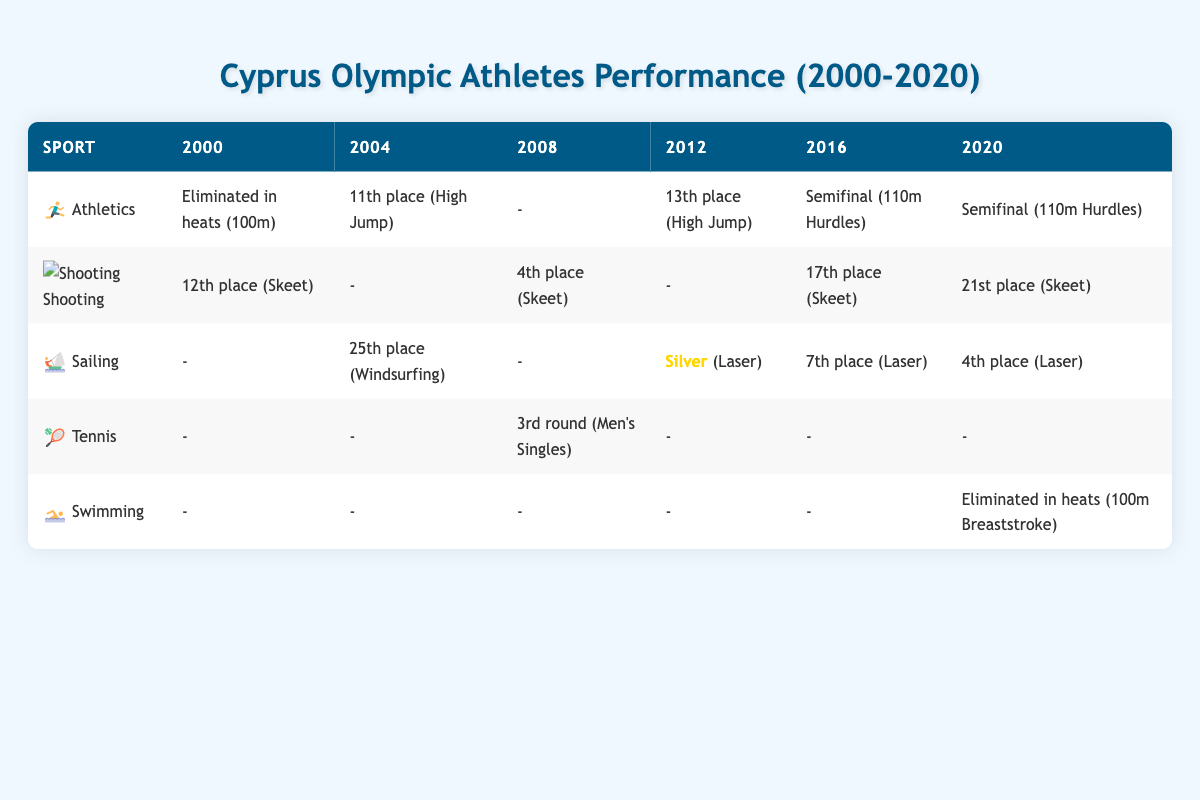What was Pavlos Kontides' best result in the Olympic Games from 2000 to 2020? Pavlos Kontides participated in the Olympics in 2012, 2016, and 2020. In 2012, he won a silver medal in the Laser event, which is his best result. In 2016, he placed 7th and in 2020 he finished 4th.
Answer: Silver How many times did Georgios Achilleos compete in the Olympics between 2000 and 2020? Georgios Achilleos competed in the Olympics in the years 2000 and 2008, thus participating twice.
Answer: 2 Did any Cypriot athlete win a medal in the Olympics from 2000 to 2020? Yes, Pavlos Kontides won a silver medal in the Laser event in 2012.
Answer: Yes Which sport had the best performance based on the highest placement across all years? When considering placements, sailing had the best performance with a silver medal in 2012. Furthermore, Kontides consistently performed well with 4th and 7th places in subsequent Olympics.
Answer: Sailing How many athletes participated in Athletics from 2000 to 2020 based on the data? The athletes in Athletics are Anninos Marcoullides, Kyriakos Ioannou, and Milan Trajkovic. They competed in 2000, 2004, 2012, 2016, and 2020, totaling three athletes.
Answer: 3 What was the overall trend for Cypriot athletes in the swimming events from 2000 to 2020? There were no successful placements for swimming as the athlete Marilena Makri was eliminated in heats in 2020, indicating a lack of advancement in this sport in the Olympics.
Answer: No advancement Which year did Pavlos Kontides achieve his highest Olympic result? Kontides achieved his highest result in 2012 when he won the silver medal in the Laser event, which is the only medal among Cypriot athletes in this period.
Answer: 2012 What are the placements of Milan Trajkovic in Athletics events during the Olympics? Milan Trajkovic participated in 2016 and 2020 in the 110m Hurdles. He reached the semifinals in both years. Therefore, he performed consistently without advancing further.
Answer: Semifinal In which events did athletes from Cyprus achieve elimination within heats? Anninos Marcoullides in the 100m Athletics in 2000 and Marilena Makri in 100m Breaststroke swimming in 2020 both had their Olympic journeys cut short in the heats.
Answer: 100m Athletics and 100m Breaststroke 